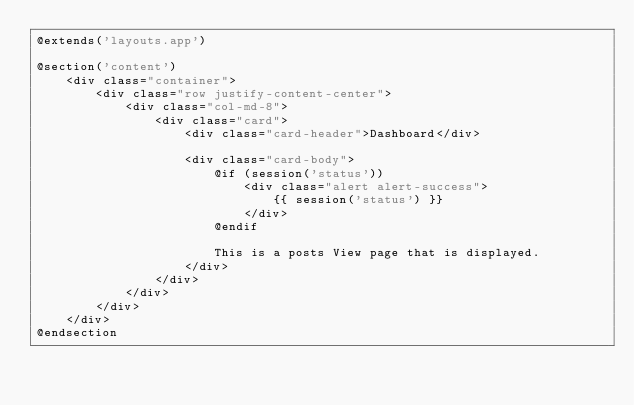<code> <loc_0><loc_0><loc_500><loc_500><_PHP_>@extends('layouts.app')

@section('content')
    <div class="container">
        <div class="row justify-content-center">
            <div class="col-md-8">
                <div class="card">
                    <div class="card-header">Dashboard</div>

                    <div class="card-body">
                        @if (session('status'))
                            <div class="alert alert-success">
                                {{ session('status') }}
                            </div>
                        @endif

                        This is a posts View page that is displayed.
                    </div>
                </div>
            </div>
        </div>
    </div>
@endsection
</code> 